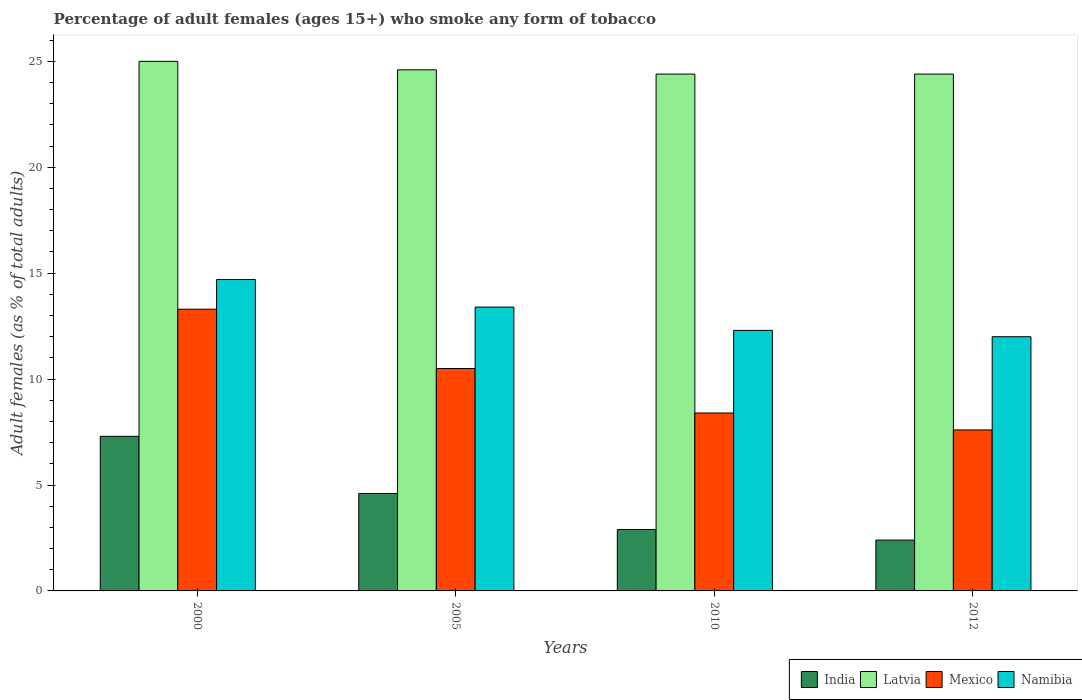Are the number of bars on each tick of the X-axis equal?
Your answer should be very brief. Yes. How many bars are there on the 2nd tick from the right?
Your response must be concise. 4. In how many cases, is the number of bars for a given year not equal to the number of legend labels?
Offer a terse response. 0. What is the percentage of adult females who smoke in Mexico in 2012?
Make the answer very short. 7.6. Across all years, what is the maximum percentage of adult females who smoke in India?
Your answer should be very brief. 7.3. In which year was the percentage of adult females who smoke in Namibia minimum?
Offer a very short reply. 2012. What is the total percentage of adult females who smoke in Mexico in the graph?
Keep it short and to the point. 39.8. What is the difference between the percentage of adult females who smoke in Mexico in 2010 and that in 2012?
Your answer should be very brief. 0.8. What is the difference between the percentage of adult females who smoke in Latvia in 2010 and the percentage of adult females who smoke in Namibia in 2012?
Provide a short and direct response. 12.4. What is the average percentage of adult females who smoke in Latvia per year?
Provide a succinct answer. 24.6. In the year 2005, what is the difference between the percentage of adult females who smoke in India and percentage of adult females who smoke in Mexico?
Provide a short and direct response. -5.9. What is the ratio of the percentage of adult females who smoke in Namibia in 2000 to that in 2010?
Provide a short and direct response. 1.2. Is the percentage of adult females who smoke in Mexico in 2000 less than that in 2012?
Give a very brief answer. No. Is the difference between the percentage of adult females who smoke in India in 2005 and 2012 greater than the difference between the percentage of adult females who smoke in Mexico in 2005 and 2012?
Ensure brevity in your answer.  No. What is the difference between the highest and the second highest percentage of adult females who smoke in India?
Offer a very short reply. 2.7. What is the difference between the highest and the lowest percentage of adult females who smoke in Namibia?
Offer a very short reply. 2.7. Is it the case that in every year, the sum of the percentage of adult females who smoke in Mexico and percentage of adult females who smoke in India is greater than the sum of percentage of adult females who smoke in Namibia and percentage of adult females who smoke in Latvia?
Provide a short and direct response. No. What does the 4th bar from the left in 2005 represents?
Your response must be concise. Namibia. What does the 1st bar from the right in 2005 represents?
Give a very brief answer. Namibia. Are all the bars in the graph horizontal?
Your answer should be very brief. No. How many years are there in the graph?
Your response must be concise. 4. Are the values on the major ticks of Y-axis written in scientific E-notation?
Offer a very short reply. No. How many legend labels are there?
Offer a very short reply. 4. What is the title of the graph?
Keep it short and to the point. Percentage of adult females (ages 15+) who smoke any form of tobacco. Does "Cambodia" appear as one of the legend labels in the graph?
Make the answer very short. No. What is the label or title of the Y-axis?
Make the answer very short. Adult females (as % of total adults). What is the Adult females (as % of total adults) in Mexico in 2000?
Offer a terse response. 13.3. What is the Adult females (as % of total adults) of Namibia in 2000?
Offer a terse response. 14.7. What is the Adult females (as % of total adults) of Latvia in 2005?
Provide a succinct answer. 24.6. What is the Adult females (as % of total adults) in Mexico in 2005?
Offer a very short reply. 10.5. What is the Adult females (as % of total adults) in Namibia in 2005?
Offer a very short reply. 13.4. What is the Adult females (as % of total adults) in Latvia in 2010?
Offer a terse response. 24.4. What is the Adult females (as % of total adults) in Mexico in 2010?
Provide a short and direct response. 8.4. What is the Adult females (as % of total adults) in Namibia in 2010?
Your answer should be compact. 12.3. What is the Adult females (as % of total adults) in India in 2012?
Give a very brief answer. 2.4. What is the Adult females (as % of total adults) in Latvia in 2012?
Keep it short and to the point. 24.4. What is the Adult females (as % of total adults) in Namibia in 2012?
Provide a succinct answer. 12. Across all years, what is the maximum Adult females (as % of total adults) of Latvia?
Offer a very short reply. 25. Across all years, what is the maximum Adult females (as % of total adults) in Mexico?
Your answer should be compact. 13.3. Across all years, what is the minimum Adult females (as % of total adults) of India?
Provide a succinct answer. 2.4. Across all years, what is the minimum Adult females (as % of total adults) in Latvia?
Give a very brief answer. 24.4. Across all years, what is the minimum Adult females (as % of total adults) of Mexico?
Offer a very short reply. 7.6. What is the total Adult females (as % of total adults) in India in the graph?
Provide a short and direct response. 17.2. What is the total Adult females (as % of total adults) in Latvia in the graph?
Make the answer very short. 98.4. What is the total Adult females (as % of total adults) in Mexico in the graph?
Offer a terse response. 39.8. What is the total Adult females (as % of total adults) in Namibia in the graph?
Your answer should be very brief. 52.4. What is the difference between the Adult females (as % of total adults) of Latvia in 2000 and that in 2005?
Your answer should be very brief. 0.4. What is the difference between the Adult females (as % of total adults) of Namibia in 2000 and that in 2005?
Provide a succinct answer. 1.3. What is the difference between the Adult females (as % of total adults) of India in 2000 and that in 2010?
Keep it short and to the point. 4.4. What is the difference between the Adult females (as % of total adults) of Namibia in 2000 and that in 2010?
Ensure brevity in your answer.  2.4. What is the difference between the Adult females (as % of total adults) in Latvia in 2000 and that in 2012?
Provide a succinct answer. 0.6. What is the difference between the Adult females (as % of total adults) of Mexico in 2000 and that in 2012?
Keep it short and to the point. 5.7. What is the difference between the Adult females (as % of total adults) in India in 2005 and that in 2010?
Ensure brevity in your answer.  1.7. What is the difference between the Adult females (as % of total adults) of Mexico in 2005 and that in 2010?
Your answer should be compact. 2.1. What is the difference between the Adult females (as % of total adults) of Latvia in 2005 and that in 2012?
Provide a succinct answer. 0.2. What is the difference between the Adult females (as % of total adults) of Mexico in 2005 and that in 2012?
Give a very brief answer. 2.9. What is the difference between the Adult females (as % of total adults) in Namibia in 2005 and that in 2012?
Give a very brief answer. 1.4. What is the difference between the Adult females (as % of total adults) in India in 2010 and that in 2012?
Make the answer very short. 0.5. What is the difference between the Adult females (as % of total adults) in Latvia in 2010 and that in 2012?
Offer a very short reply. 0. What is the difference between the Adult females (as % of total adults) of India in 2000 and the Adult females (as % of total adults) of Latvia in 2005?
Ensure brevity in your answer.  -17.3. What is the difference between the Adult females (as % of total adults) in Latvia in 2000 and the Adult females (as % of total adults) in Mexico in 2005?
Your answer should be very brief. 14.5. What is the difference between the Adult females (as % of total adults) of Mexico in 2000 and the Adult females (as % of total adults) of Namibia in 2005?
Give a very brief answer. -0.1. What is the difference between the Adult females (as % of total adults) of India in 2000 and the Adult females (as % of total adults) of Latvia in 2010?
Your answer should be very brief. -17.1. What is the difference between the Adult females (as % of total adults) in India in 2000 and the Adult females (as % of total adults) in Namibia in 2010?
Give a very brief answer. -5. What is the difference between the Adult females (as % of total adults) in Latvia in 2000 and the Adult females (as % of total adults) in Mexico in 2010?
Offer a terse response. 16.6. What is the difference between the Adult females (as % of total adults) in Latvia in 2000 and the Adult females (as % of total adults) in Namibia in 2010?
Your answer should be compact. 12.7. What is the difference between the Adult females (as % of total adults) of Mexico in 2000 and the Adult females (as % of total adults) of Namibia in 2010?
Give a very brief answer. 1. What is the difference between the Adult females (as % of total adults) of India in 2000 and the Adult females (as % of total adults) of Latvia in 2012?
Ensure brevity in your answer.  -17.1. What is the difference between the Adult females (as % of total adults) in India in 2000 and the Adult females (as % of total adults) in Mexico in 2012?
Make the answer very short. -0.3. What is the difference between the Adult females (as % of total adults) of India in 2000 and the Adult females (as % of total adults) of Namibia in 2012?
Provide a succinct answer. -4.7. What is the difference between the Adult females (as % of total adults) of Latvia in 2000 and the Adult females (as % of total adults) of Mexico in 2012?
Offer a terse response. 17.4. What is the difference between the Adult females (as % of total adults) in Mexico in 2000 and the Adult females (as % of total adults) in Namibia in 2012?
Your answer should be compact. 1.3. What is the difference between the Adult females (as % of total adults) in India in 2005 and the Adult females (as % of total adults) in Latvia in 2010?
Provide a succinct answer. -19.8. What is the difference between the Adult females (as % of total adults) in India in 2005 and the Adult females (as % of total adults) in Mexico in 2010?
Offer a very short reply. -3.8. What is the difference between the Adult females (as % of total adults) of India in 2005 and the Adult females (as % of total adults) of Namibia in 2010?
Provide a short and direct response. -7.7. What is the difference between the Adult females (as % of total adults) of Latvia in 2005 and the Adult females (as % of total adults) of Namibia in 2010?
Offer a very short reply. 12.3. What is the difference between the Adult females (as % of total adults) in India in 2005 and the Adult females (as % of total adults) in Latvia in 2012?
Offer a terse response. -19.8. What is the difference between the Adult females (as % of total adults) of India in 2005 and the Adult females (as % of total adults) of Namibia in 2012?
Offer a very short reply. -7.4. What is the difference between the Adult females (as % of total adults) in Latvia in 2005 and the Adult females (as % of total adults) in Namibia in 2012?
Your answer should be compact. 12.6. What is the difference between the Adult females (as % of total adults) in India in 2010 and the Adult females (as % of total adults) in Latvia in 2012?
Offer a terse response. -21.5. What is the difference between the Adult females (as % of total adults) of India in 2010 and the Adult females (as % of total adults) of Mexico in 2012?
Offer a very short reply. -4.7. What is the difference between the Adult females (as % of total adults) in Latvia in 2010 and the Adult females (as % of total adults) in Mexico in 2012?
Your answer should be compact. 16.8. What is the difference between the Adult females (as % of total adults) in Latvia in 2010 and the Adult females (as % of total adults) in Namibia in 2012?
Offer a very short reply. 12.4. What is the difference between the Adult females (as % of total adults) of Mexico in 2010 and the Adult females (as % of total adults) of Namibia in 2012?
Your response must be concise. -3.6. What is the average Adult females (as % of total adults) in Latvia per year?
Offer a terse response. 24.6. What is the average Adult females (as % of total adults) in Mexico per year?
Provide a succinct answer. 9.95. In the year 2000, what is the difference between the Adult females (as % of total adults) in India and Adult females (as % of total adults) in Latvia?
Keep it short and to the point. -17.7. In the year 2000, what is the difference between the Adult females (as % of total adults) in India and Adult females (as % of total adults) in Mexico?
Your answer should be compact. -6. In the year 2000, what is the difference between the Adult females (as % of total adults) in Latvia and Adult females (as % of total adults) in Mexico?
Provide a succinct answer. 11.7. In the year 2000, what is the difference between the Adult females (as % of total adults) in Mexico and Adult females (as % of total adults) in Namibia?
Ensure brevity in your answer.  -1.4. In the year 2005, what is the difference between the Adult females (as % of total adults) in Latvia and Adult females (as % of total adults) in Mexico?
Offer a very short reply. 14.1. In the year 2010, what is the difference between the Adult females (as % of total adults) in India and Adult females (as % of total adults) in Latvia?
Offer a very short reply. -21.5. In the year 2010, what is the difference between the Adult females (as % of total adults) in India and Adult females (as % of total adults) in Namibia?
Offer a very short reply. -9.4. In the year 2010, what is the difference between the Adult females (as % of total adults) in Latvia and Adult females (as % of total adults) in Mexico?
Offer a terse response. 16. In the year 2010, what is the difference between the Adult females (as % of total adults) of Mexico and Adult females (as % of total adults) of Namibia?
Make the answer very short. -3.9. In the year 2012, what is the difference between the Adult females (as % of total adults) in India and Adult females (as % of total adults) in Mexico?
Your response must be concise. -5.2. In the year 2012, what is the difference between the Adult females (as % of total adults) in India and Adult females (as % of total adults) in Namibia?
Keep it short and to the point. -9.6. In the year 2012, what is the difference between the Adult females (as % of total adults) in Latvia and Adult females (as % of total adults) in Namibia?
Your answer should be compact. 12.4. What is the ratio of the Adult females (as % of total adults) in India in 2000 to that in 2005?
Offer a terse response. 1.59. What is the ratio of the Adult females (as % of total adults) of Latvia in 2000 to that in 2005?
Provide a short and direct response. 1.02. What is the ratio of the Adult females (as % of total adults) in Mexico in 2000 to that in 2005?
Give a very brief answer. 1.27. What is the ratio of the Adult females (as % of total adults) in Namibia in 2000 to that in 2005?
Provide a succinct answer. 1.1. What is the ratio of the Adult females (as % of total adults) of India in 2000 to that in 2010?
Offer a terse response. 2.52. What is the ratio of the Adult females (as % of total adults) in Latvia in 2000 to that in 2010?
Your answer should be compact. 1.02. What is the ratio of the Adult females (as % of total adults) of Mexico in 2000 to that in 2010?
Make the answer very short. 1.58. What is the ratio of the Adult females (as % of total adults) of Namibia in 2000 to that in 2010?
Keep it short and to the point. 1.2. What is the ratio of the Adult females (as % of total adults) of India in 2000 to that in 2012?
Provide a short and direct response. 3.04. What is the ratio of the Adult females (as % of total adults) in Latvia in 2000 to that in 2012?
Offer a very short reply. 1.02. What is the ratio of the Adult females (as % of total adults) in Namibia in 2000 to that in 2012?
Offer a very short reply. 1.23. What is the ratio of the Adult females (as % of total adults) in India in 2005 to that in 2010?
Keep it short and to the point. 1.59. What is the ratio of the Adult females (as % of total adults) in Latvia in 2005 to that in 2010?
Offer a very short reply. 1.01. What is the ratio of the Adult females (as % of total adults) in Mexico in 2005 to that in 2010?
Offer a terse response. 1.25. What is the ratio of the Adult females (as % of total adults) in Namibia in 2005 to that in 2010?
Provide a succinct answer. 1.09. What is the ratio of the Adult females (as % of total adults) in India in 2005 to that in 2012?
Offer a terse response. 1.92. What is the ratio of the Adult females (as % of total adults) of Latvia in 2005 to that in 2012?
Offer a very short reply. 1.01. What is the ratio of the Adult females (as % of total adults) of Mexico in 2005 to that in 2012?
Offer a terse response. 1.38. What is the ratio of the Adult females (as % of total adults) in Namibia in 2005 to that in 2012?
Keep it short and to the point. 1.12. What is the ratio of the Adult females (as % of total adults) of India in 2010 to that in 2012?
Your answer should be compact. 1.21. What is the ratio of the Adult females (as % of total adults) of Latvia in 2010 to that in 2012?
Give a very brief answer. 1. What is the ratio of the Adult females (as % of total adults) of Mexico in 2010 to that in 2012?
Make the answer very short. 1.11. What is the ratio of the Adult females (as % of total adults) in Namibia in 2010 to that in 2012?
Ensure brevity in your answer.  1.02. What is the difference between the highest and the second highest Adult females (as % of total adults) of Latvia?
Your answer should be compact. 0.4. What is the difference between the highest and the second highest Adult females (as % of total adults) in Mexico?
Offer a very short reply. 2.8. What is the difference between the highest and the second highest Adult females (as % of total adults) of Namibia?
Your answer should be compact. 1.3. What is the difference between the highest and the lowest Adult females (as % of total adults) of India?
Your answer should be compact. 4.9. What is the difference between the highest and the lowest Adult females (as % of total adults) of Latvia?
Your answer should be very brief. 0.6. What is the difference between the highest and the lowest Adult females (as % of total adults) in Mexico?
Make the answer very short. 5.7. 